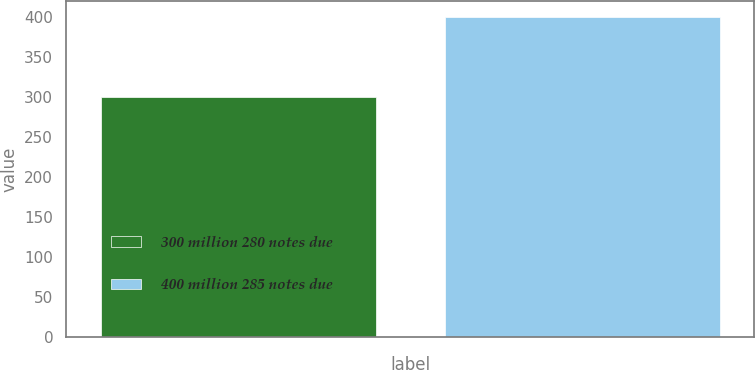Convert chart to OTSL. <chart><loc_0><loc_0><loc_500><loc_500><bar_chart><fcel>300 million 280 notes due<fcel>400 million 285 notes due<nl><fcel>299.8<fcel>399.6<nl></chart> 